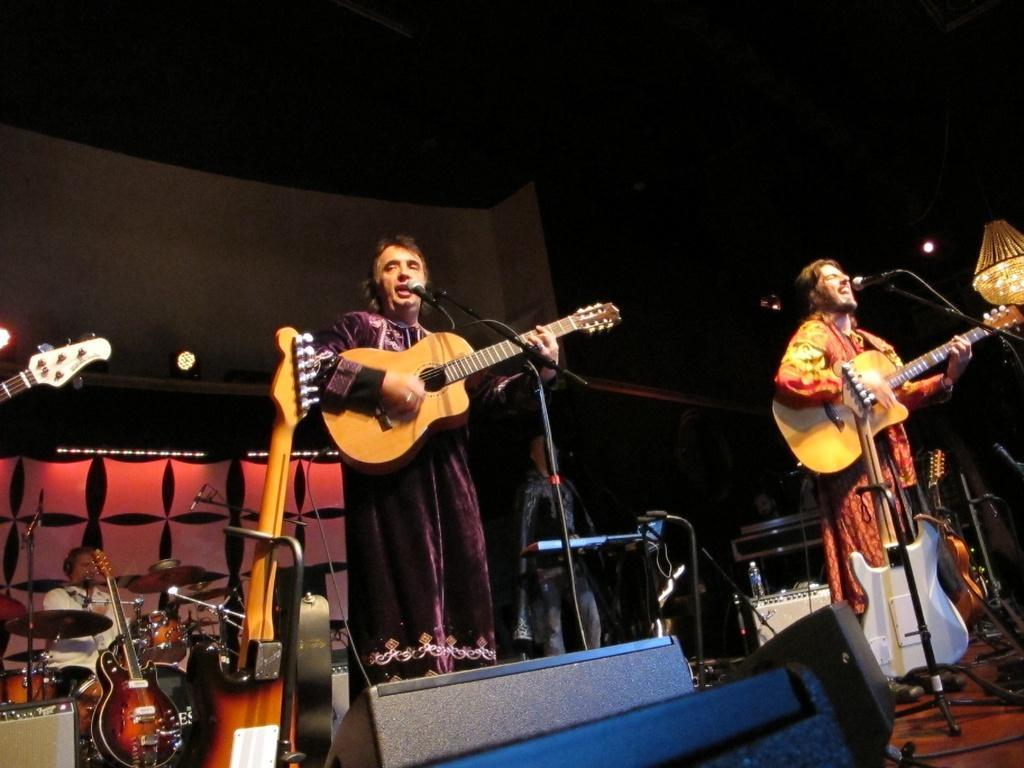How would you summarize this image in a sentence or two? This is picture of a concert. Two persons on the foreground are singing along with playing guitar. There is microphone in front of them. Which is attached to respective stands. There are guitars in the stand. In the background a person is playing drum. In the background in the middle another person is playing keyboard. There is a chandelier in the right corner. In the background there are lights,curtain. There is a carpet on the floor. 